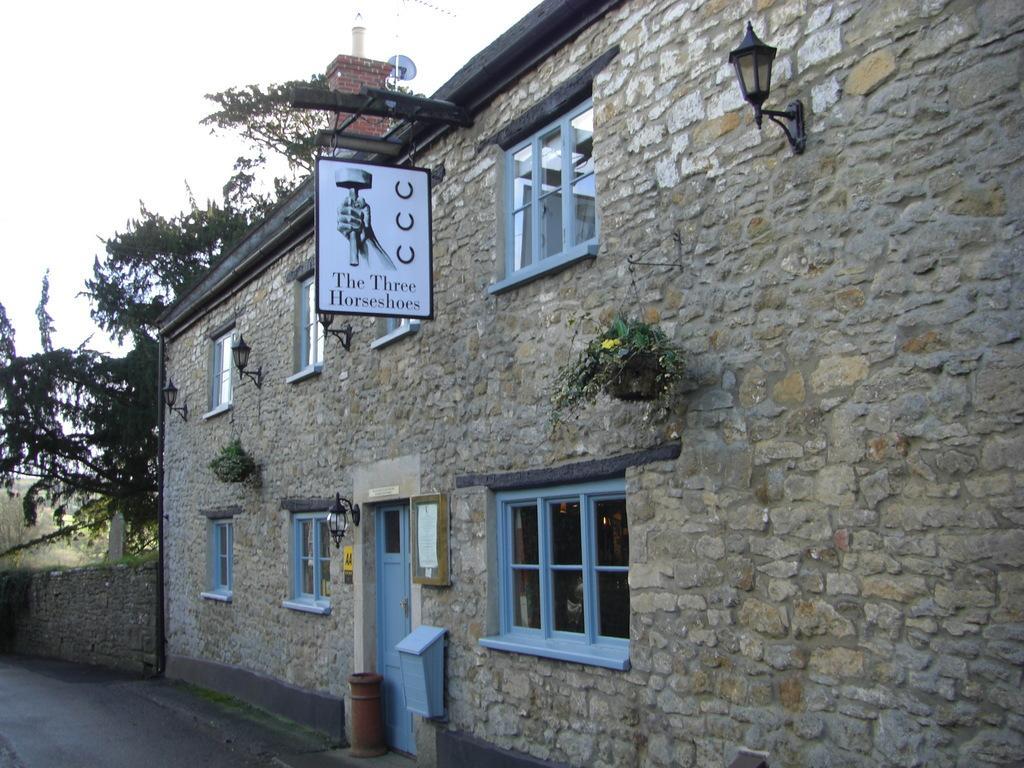Describe this image in one or two sentences. In this picture we can see a building with windows, lights, plants, a door, and a board. On the left side of the building there is a wall and trees. Behind the trees there is the sky. 